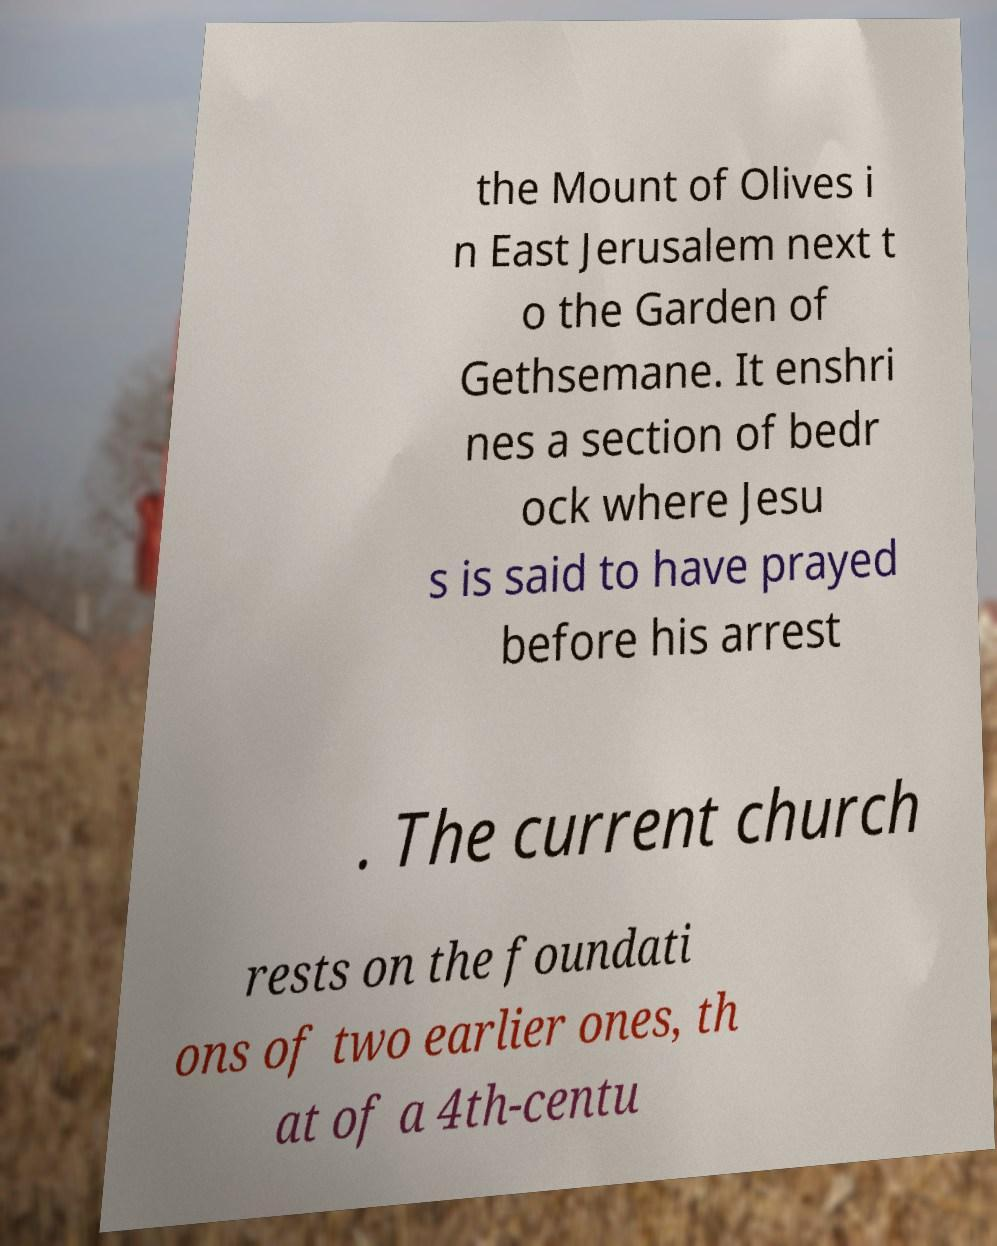Please read and relay the text visible in this image. What does it say? the Mount of Olives i n East Jerusalem next t o the Garden of Gethsemane. It enshri nes a section of bedr ock where Jesu s is said to have prayed before his arrest . The current church rests on the foundati ons of two earlier ones, th at of a 4th-centu 